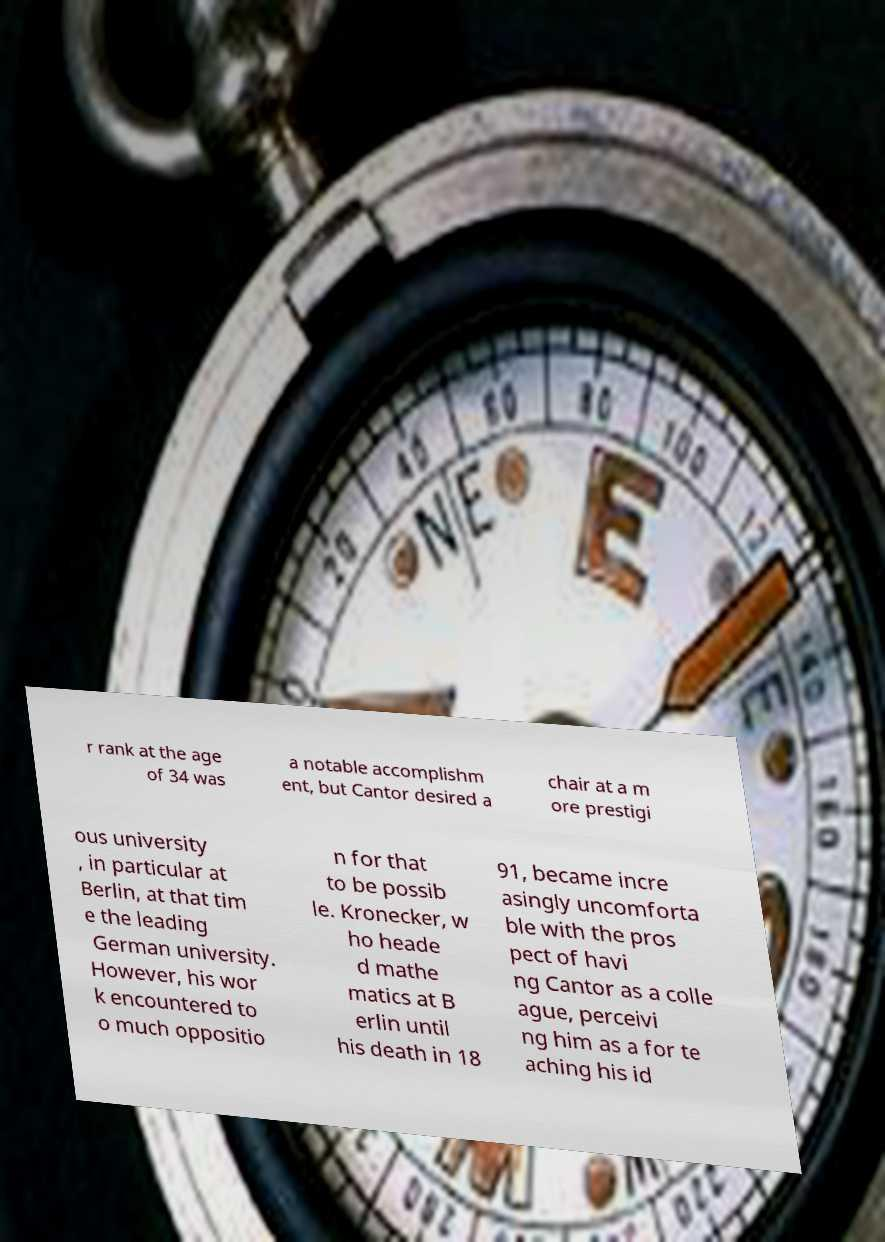I need the written content from this picture converted into text. Can you do that? r rank at the age of 34 was a notable accomplishm ent, but Cantor desired a chair at a m ore prestigi ous university , in particular at Berlin, at that tim e the leading German university. However, his wor k encountered to o much oppositio n for that to be possib le. Kronecker, w ho heade d mathe matics at B erlin until his death in 18 91, became incre asingly uncomforta ble with the pros pect of havi ng Cantor as a colle ague, perceivi ng him as a for te aching his id 